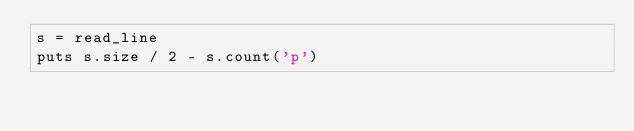<code> <loc_0><loc_0><loc_500><loc_500><_Crystal_>s = read_line
puts s.size / 2 - s.count('p')</code> 